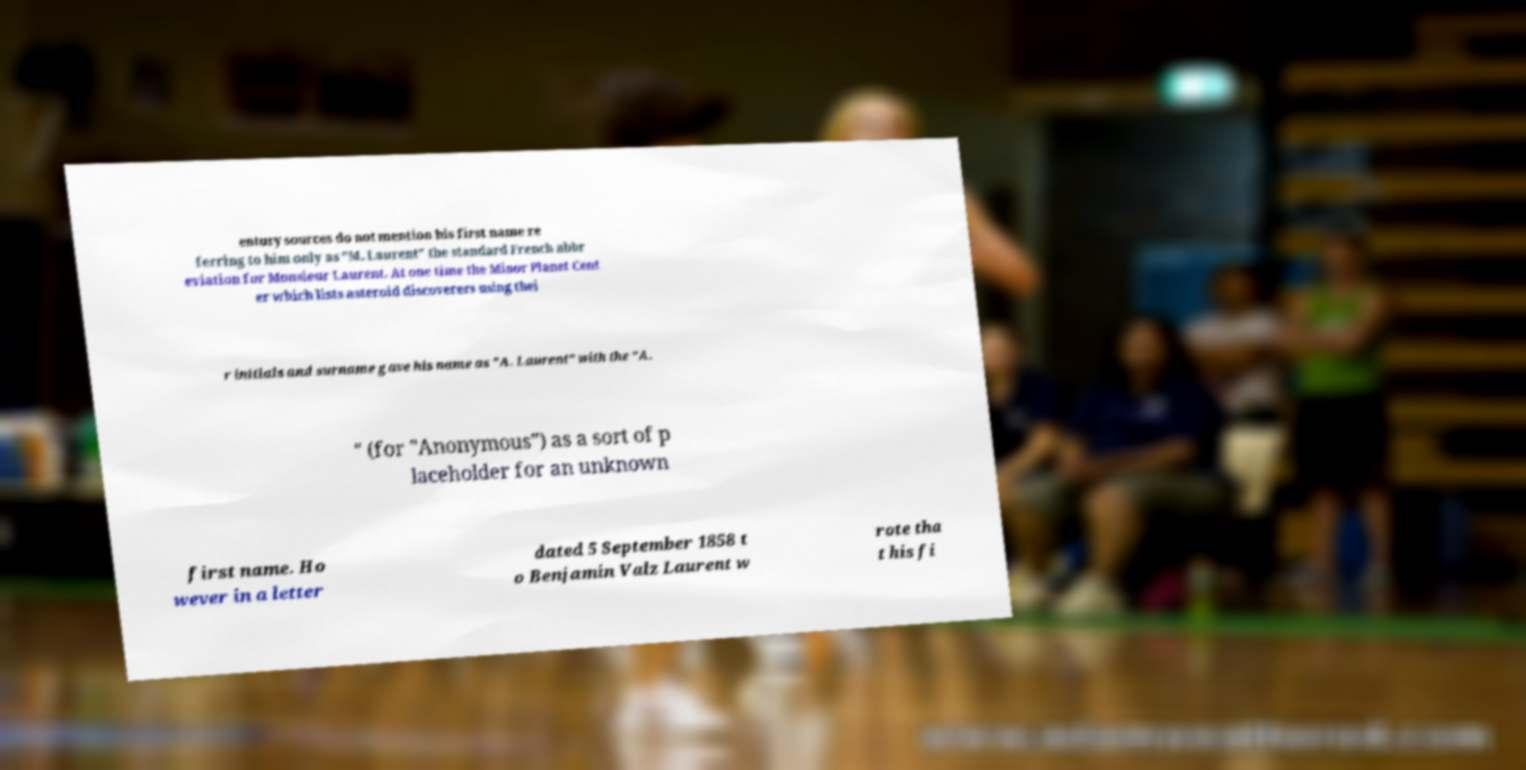There's text embedded in this image that I need extracted. Can you transcribe it verbatim? entury sources do not mention his first name re ferring to him only as "M. Laurent" the standard French abbr eviation for Monsieur Laurent. At one time the Minor Planet Cent er which lists asteroid discoverers using thei r initials and surname gave his name as "A. Laurent" with the "A. " (for "Anonymous") as a sort of p laceholder for an unknown first name. Ho wever in a letter dated 5 September 1858 t o Benjamin Valz Laurent w rote tha t his fi 